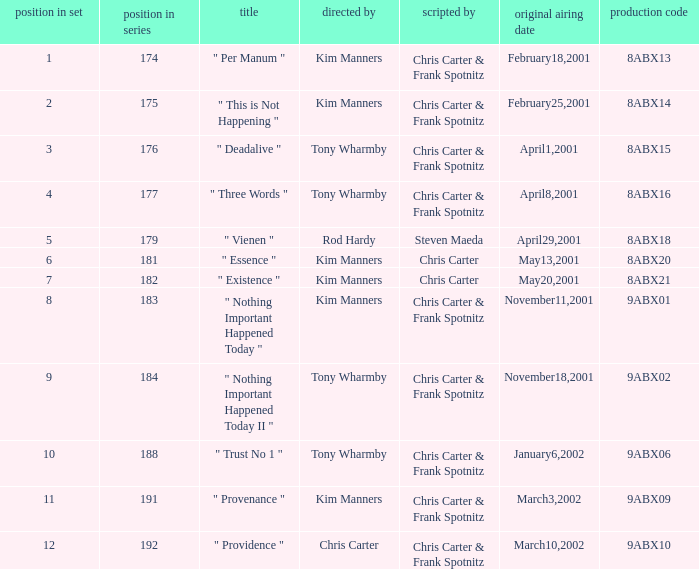What is the episode number that has production code 8abx15? 176.0. 